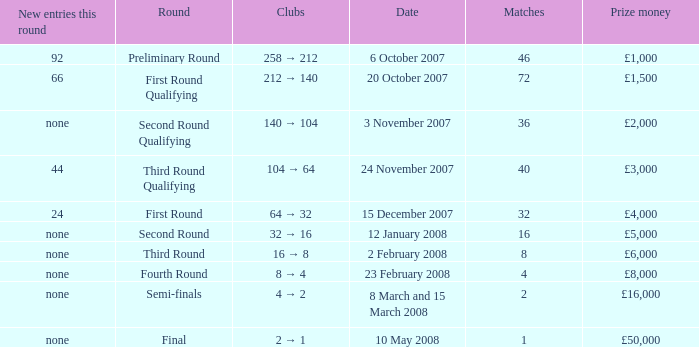How many new entries this round have clubs 2 → 1? None. 